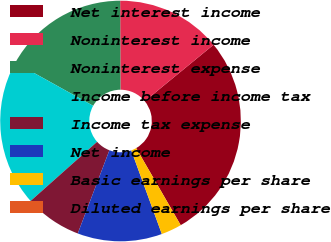Convert chart. <chart><loc_0><loc_0><loc_500><loc_500><pie_chart><fcel>Net interest income<fcel>Noninterest income<fcel>Noninterest expense<fcel>Income before income tax<fcel>Income tax expense<fcel>Net income<fcel>Basic earnings per share<fcel>Diluted earnings per share<nl><fcel>27.59%<fcel>14.12%<fcel>16.88%<fcel>19.64%<fcel>7.65%<fcel>11.36%<fcel>2.76%<fcel>0.0%<nl></chart> 